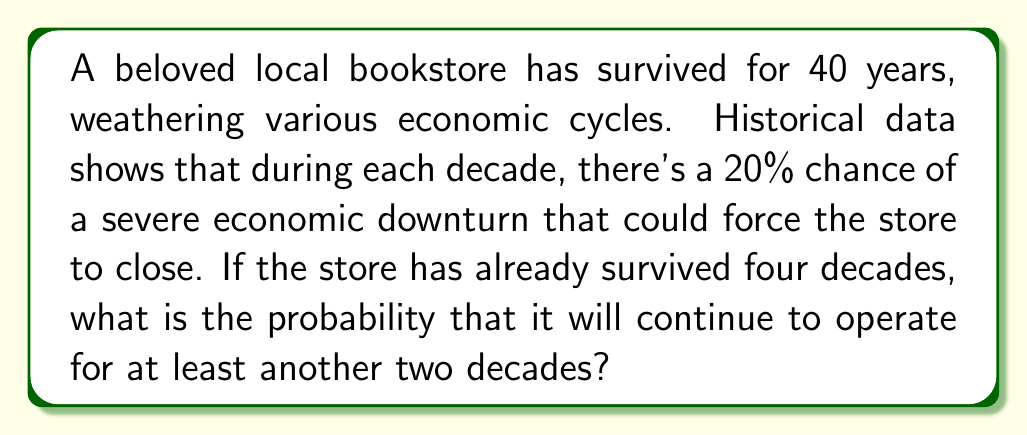Give your solution to this math problem. To solve this problem, we need to follow these steps:

1) First, we need to calculate the probability of the bookstore surviving one decade. Since there's a 20% chance of closure, the probability of survival for one decade is:

   $P(\text{survive one decade}) = 1 - 0.20 = 0.80$ or $80\%$

2) Now, we need to find the probability of surviving two more decades. This is equivalent to surviving two consecutive decades. Since these events are independent, we multiply the probabilities:

   $P(\text{survive two decades}) = 0.80 \times 0.80 = 0.64$

3) We can express this calculation using exponents:

   $P(\text{survive two decades}) = 0.80^2 = 0.64$

4) Therefore, the probability that the bookstore will continue to operate for at least another two decades is 0.64 or 64%.

This calculation assumes that the probability of an economic downturn remains constant over time and that each decade's survival is independent of the others. In reality, economic conditions may change, and a store's resilience might increase with experience, but this simplified model gives us a reasonable estimate.
Answer: The probability that the bookstore will continue to operate for at least another two decades is $0.64$ or $64\%$. 